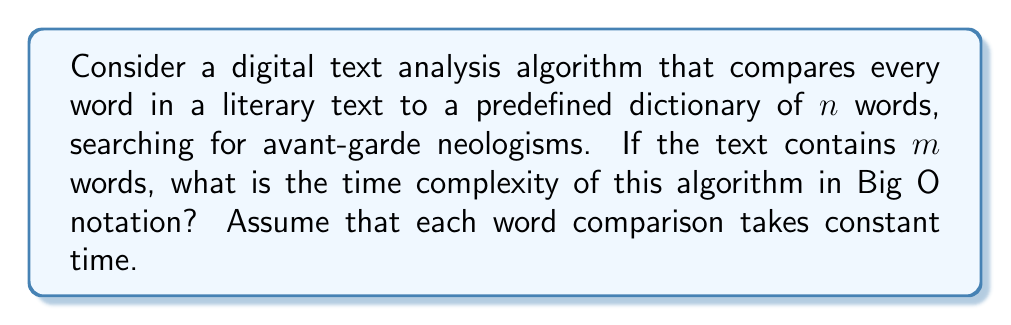What is the answer to this math problem? To analyze the computational complexity of this algorithm, let's break it down step-by-step:

1. The algorithm needs to process each word in the text. There are $m$ words in total.

2. For each word, it performs a comparison with every word in the dictionary. The dictionary contains $n$ words.

3. Each individual word comparison is assumed to take constant time, which we can denote as $O(1)$.

4. This results in a nested loop structure:
   - Outer loop: Iterates $m$ times (for each word in the text)
   - Inner loop: Iterates $n$ times (for each word in the dictionary)

5. The total number of operations is therefore $m * n$.

6. In Big O notation, we express this as $O(mn)$.

This quadratic time complexity is characteristic of algorithms that compare each element of one set to each element of another set. In the context of avant-garde literature analysis, this could represent a significant computational challenge when dealing with large texts or extensive dictionaries of neologisms.

It's worth noting that more efficient algorithms, such as those using hash tables or tries, could potentially reduce this complexity. However, the question specifically asks about the algorithm that compares every word to every dictionary entry.
Answer: $O(mn)$ 